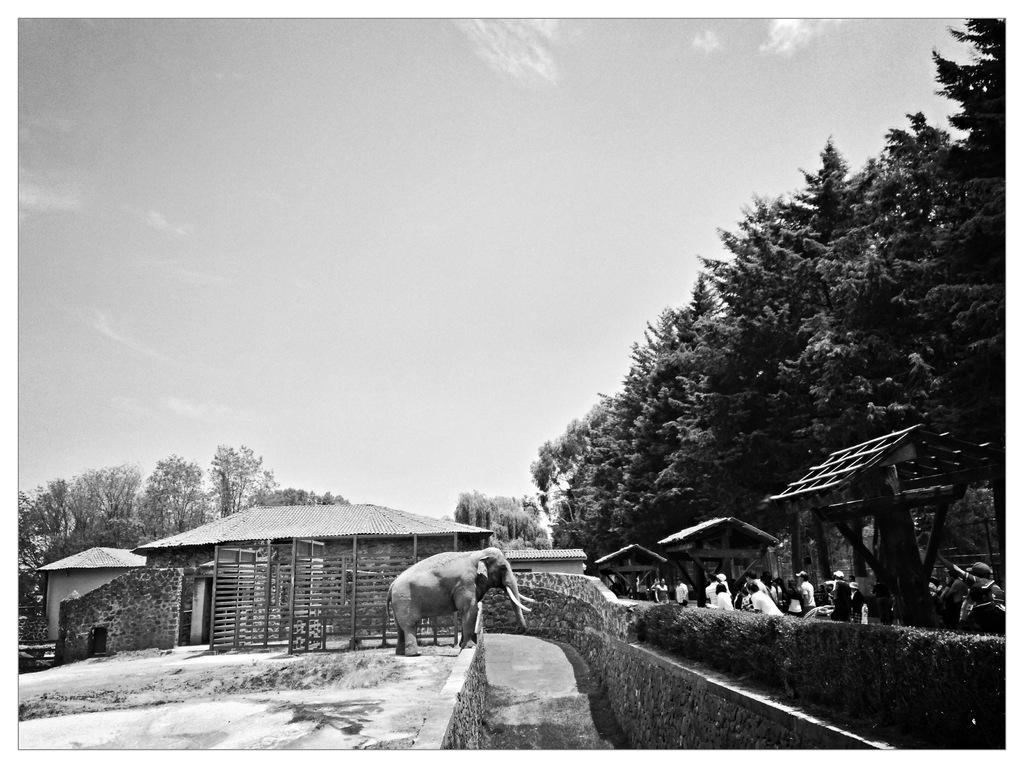What type of animal is in the image? There is an elephant in the image. What structures can be seen in the image? There are houses in the image. Who or what else is present in the image? There are people in the image. What type of vegetation is in the image? There are trees and plants in the image. What type of lunch is being served in the image? There is no lunch present in the image. Can you describe the level of detail in the image? The question about the level of detail is not relevant to the provided facts, as they do not mention any specific details or characteristics of the image. 